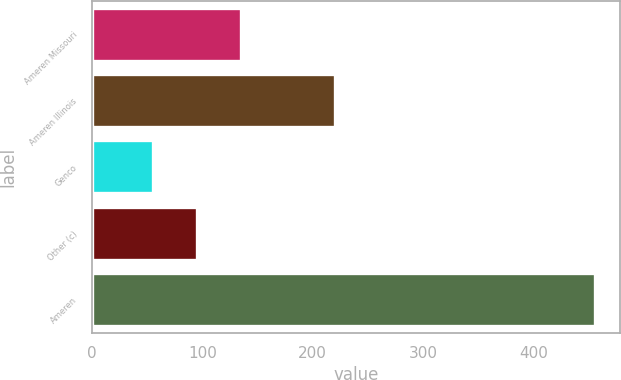Convert chart. <chart><loc_0><loc_0><loc_500><loc_500><bar_chart><fcel>Ameren Missouri<fcel>Ameren Illinois<fcel>Genco<fcel>Other (c)<fcel>Ameren<nl><fcel>135.2<fcel>220<fcel>55<fcel>95.1<fcel>456<nl></chart> 